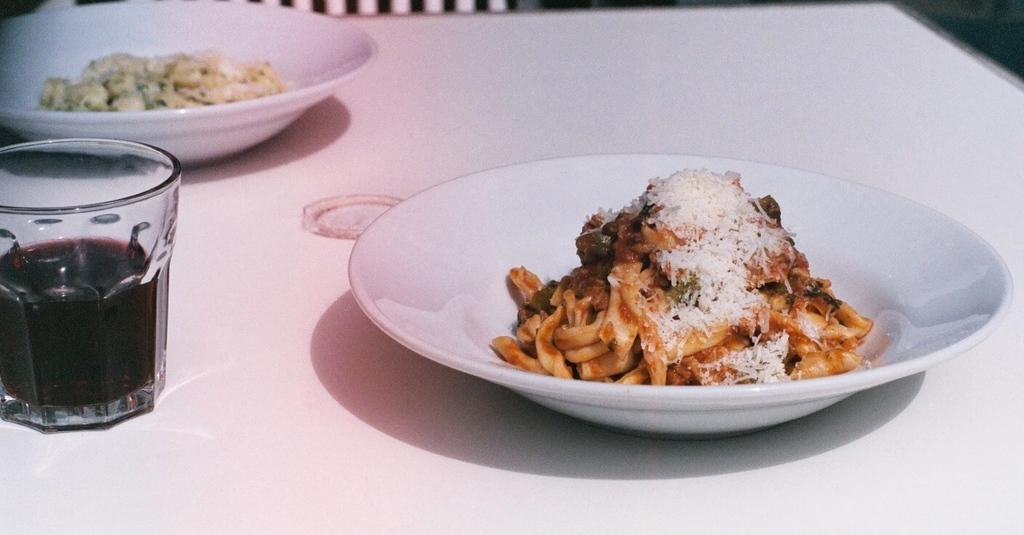What is on the white plate in the image? There is food in a white plate in the image. What type of glassware is present in the image? There is a wine glass in the image. Where is the wine glass placed? The wine glass is placed on a white table top. How many sisters are sitting at the table in the image? There is no information about any people, including sisters, in the image. 